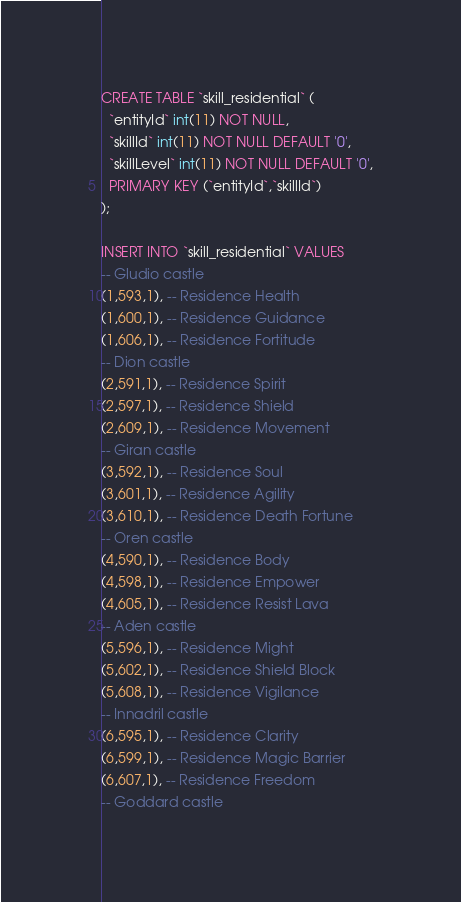<code> <loc_0><loc_0><loc_500><loc_500><_SQL_>CREATE TABLE `skill_residential` (
  `entityId` int(11) NOT NULL,
  `skillId` int(11) NOT NULL DEFAULT '0',
  `skillLevel` int(11) NOT NULL DEFAULT '0',
  PRIMARY KEY (`entityId`,`skillId`)
);

INSERT INTO `skill_residential` VALUES
-- Gludio castle
(1,593,1), -- Residence Health
(1,600,1), -- Residence Guidance
(1,606,1), -- Residence Fortitude
-- Dion castle
(2,591,1), -- Residence Spirit
(2,597,1), -- Residence Shield
(2,609,1), -- Residence Movement
-- Giran castle
(3,592,1), -- Residence Soul
(3,601,1), -- Residence Agility
(3,610,1), -- Residence Death Fortune
-- Oren castle
(4,590,1), -- Residence Body
(4,598,1), -- Residence Empower
(4,605,1), -- Residence Resist Lava
-- Aden castle
(5,596,1), -- Residence Might
(5,602,1), -- Residence Shield Block
(5,608,1), -- Residence Vigilance
-- Innadril castle
(6,595,1), -- Residence Clarity
(6,599,1), -- Residence Magic Barrier
(6,607,1), -- Residence Freedom
-- Goddard castle</code> 